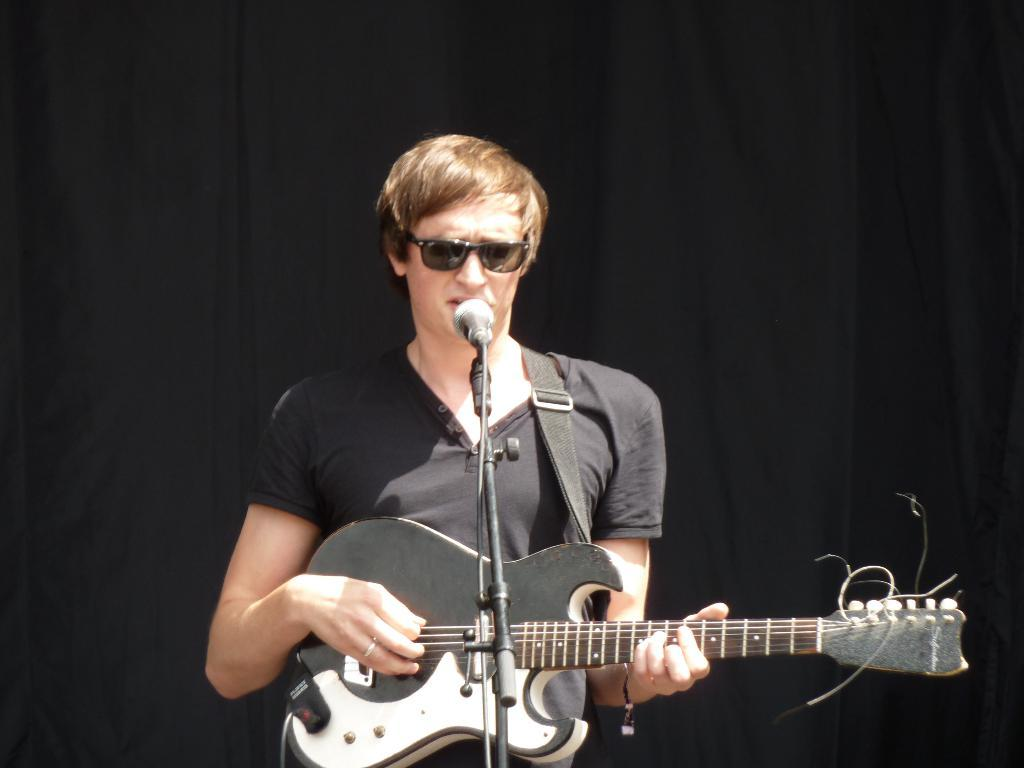What is the person in the image doing? The person is standing, playing the guitar, and singing. What object is the person using to amplify their voice? There is a microphone in the image, which is likely being used by the person. What is supporting the microphone in the image? There is a stand associated with the microphone in the image. How many beds can be seen in the image? There are no beds present in the image. What type of attention is the person receiving from the fifth person in the image? There is no mention of a fifth person in the image, so it is impossible to determine if the person is receiving any attention. 